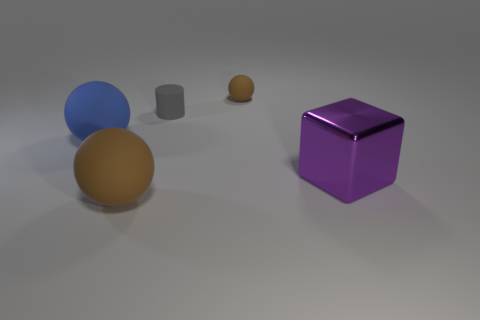What shape is the tiny brown thing that is the same material as the small cylinder?
Your answer should be very brief. Sphere. How big is the brown sphere that is behind the cube?
Ensure brevity in your answer.  Small. Are there the same number of blue rubber spheres in front of the large brown thing and spheres behind the gray thing?
Your answer should be compact. No. The large matte ball behind the brown rubber sphere in front of the tiny object in front of the small brown matte ball is what color?
Your answer should be compact. Blue. What number of things are both right of the tiny matte cylinder and behind the purple metallic thing?
Your answer should be compact. 1. Do the big object that is right of the cylinder and the large ball in front of the cube have the same color?
Offer a terse response. No. Is there any other thing that has the same material as the big block?
Give a very brief answer. No. What is the size of the other brown object that is the same shape as the big brown rubber object?
Provide a succinct answer. Small. Are there any blue matte things behind the big brown rubber object?
Your answer should be compact. Yes. Is the number of purple shiny things that are behind the tiny cylinder the same as the number of yellow cubes?
Provide a succinct answer. Yes. 